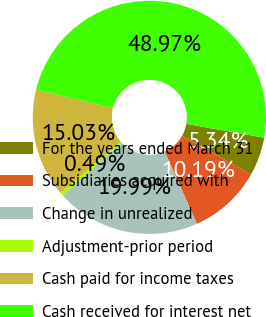Convert chart to OTSL. <chart><loc_0><loc_0><loc_500><loc_500><pie_chart><fcel>For the years ended March 31<fcel>Subsidiaries acquired with<fcel>Change in unrealized<fcel>Adjustment-prior period<fcel>Cash paid for income taxes<fcel>Cash received for interest net<nl><fcel>5.34%<fcel>10.19%<fcel>19.99%<fcel>0.49%<fcel>15.03%<fcel>48.97%<nl></chart> 